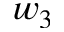Convert formula to latex. <formula><loc_0><loc_0><loc_500><loc_500>w _ { 3 }</formula> 